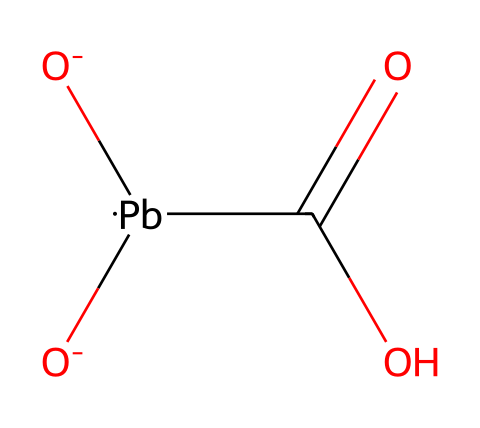What is the primary component in this chemical structure? The chemical structure contains the element lead ([Pb]), which is the primary component.
Answer: lead How many oxygen atoms are present in the chemical structure? The structure shows three oxygen atoms, seen as [O-][O-] and in the carboxylic acid group (C(=O)O).
Answer: three What type of chemical is represented by this structure? This structure represents a pigment, specifically a hazardous metal-based white pigment known as lead white.
Answer: pigment What is the oxidation state of lead in this compound? Lead in this compound has an oxidation state of +2, as indicated by its bonding with two negatively charged oxygen ions.
Answer: +2 What functional groups are present in the chemical structure? The structure contains a carboxylic acid functional group (C(=O)O) and negatively charged oxygen ions, signaling it can react with other compounds.
Answer: carboxylic acid Why is lead white considered hazardous? Lead white is hazardous due to the toxicity of lead, which can lead to poisoning upon exposure or ingestion, particularly in paint forms.
Answer: toxicity 